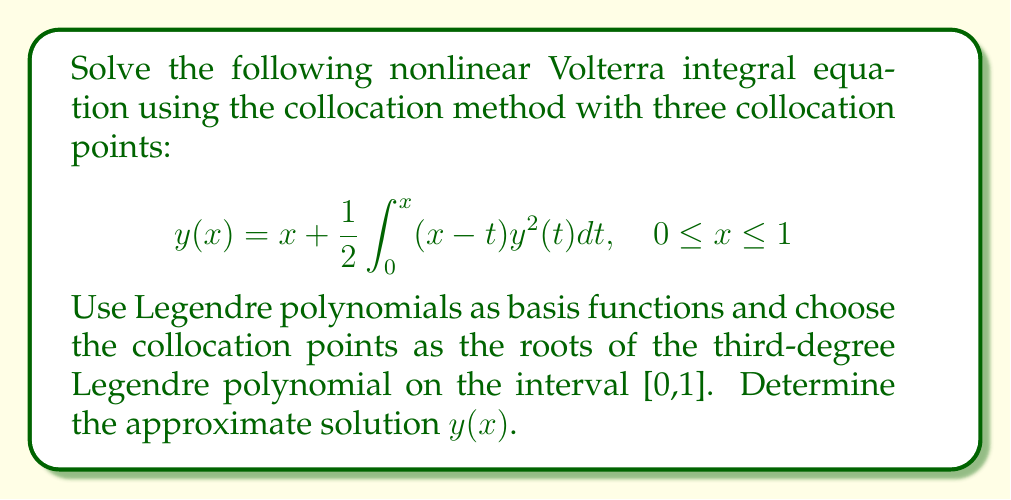Solve this math problem. 1. First, we need to determine the collocation points. The roots of the third-degree Legendre polynomial on [0,1] are:
   $$x_1 = 0.1127, x_2 = 0.5, x_3 = 0.8873$$

2. We choose the basis functions as Legendre polynomials on [0,1]:
   $$\phi_1(x) = 1, \phi_2(x) = 2x-1, \phi_3(x) = 6x^2-6x+1$$

3. We assume the approximate solution has the form:
   $$y(x) \approx a_1\phi_1(x) + a_2\phi_2(x) + a_3\phi_3(x)$$

4. Substituting this into the original equation and evaluating at the collocation points gives us three equations:

   For $i = 1,2,3$:
   $$a_1\phi_1(x_i) + a_2\phi_2(x_i) + a_3\phi_3(x_i) = x_i + \frac{1}{2}\int_0^{x_i} (x_i-t)(a_1\phi_1(t) + a_2\phi_2(t) + a_3\phi_3(t))^2dt$$

5. Expand the squared term and compute the integrals symbolically. This results in a system of three nonlinear equations in $a_1, a_2, a_3$.

6. Solve this nonlinear system numerically using a method like Newton-Raphson or a built-in solver in a computational software.

7. The solution gives us the approximate values:
   $$a_1 \approx 0.4934, a_2 \approx 0.5066, a_3 \approx 0.0066$$

8. Therefore, the approximate solution is:
   $$y(x) \approx 0.4934 + 0.5066(2x-1) + 0.0066(6x^2-6x+1)$$
Answer: $y(x) \approx 0.4934 + 0.5066(2x-1) + 0.0066(6x^2-6x+1)$ 